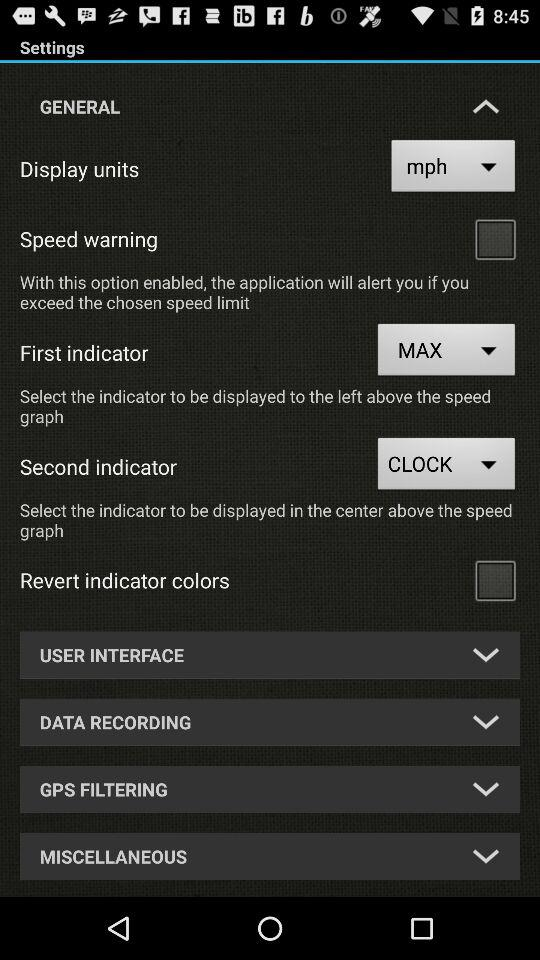What is the option selected for the first indicator? The selected option is "MAX". 